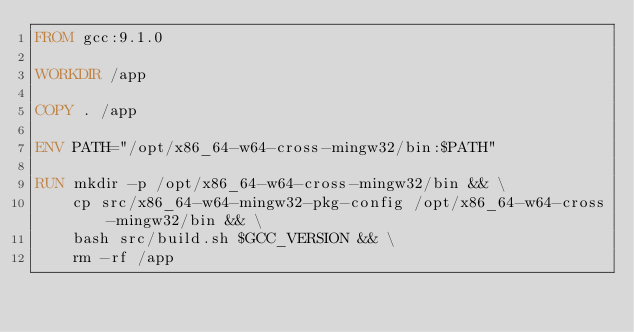Convert code to text. <code><loc_0><loc_0><loc_500><loc_500><_Dockerfile_>FROM gcc:9.1.0

WORKDIR /app

COPY . /app

ENV PATH="/opt/x86_64-w64-cross-mingw32/bin:$PATH"

RUN mkdir -p /opt/x86_64-w64-cross-mingw32/bin && \
    cp src/x86_64-w64-mingw32-pkg-config /opt/x86_64-w64-cross-mingw32/bin && \
    bash src/build.sh $GCC_VERSION && \
    rm -rf /app

</code> 